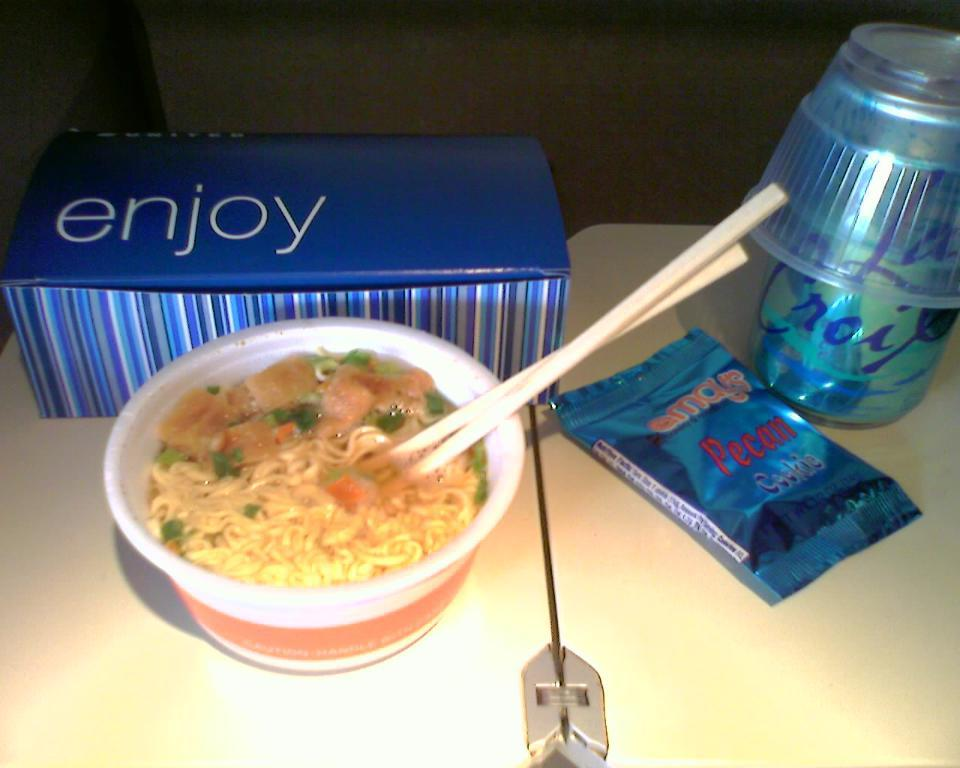<image>
Create a compact narrative representing the image presented. Someone is eating Pecan cookies and drinking La Croix with a bowl of ramen. 